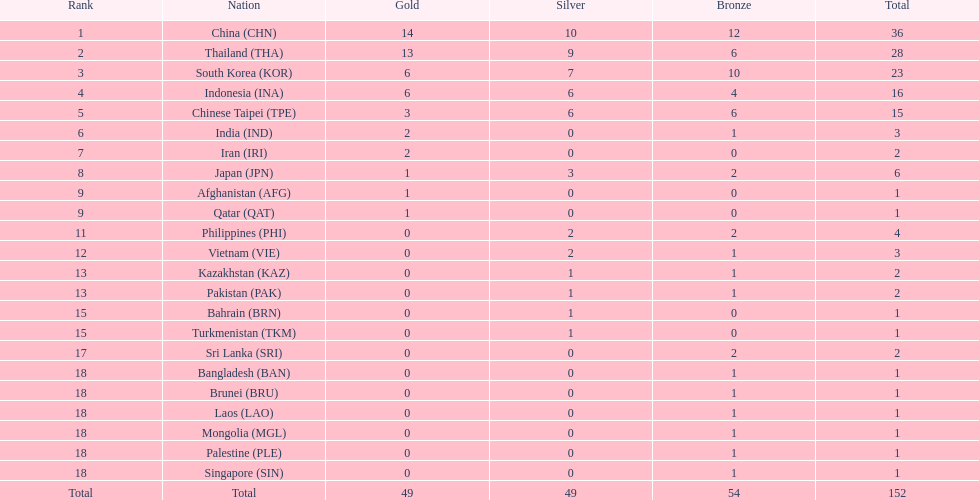What is the difference in the number of medals earned by india and pakistan? 1. 